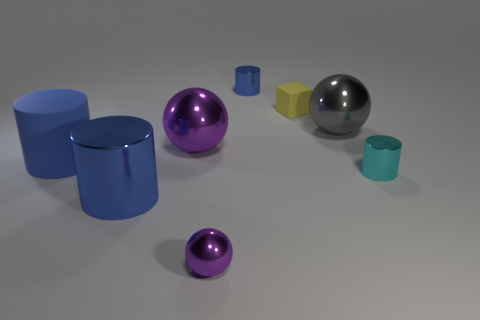Subtract all blue cylinders. How many were subtracted if there are1blue cylinders left? 2 Subtract all red blocks. How many blue cylinders are left? 3 Subtract all green cylinders. Subtract all purple spheres. How many cylinders are left? 4 Add 2 purple shiny spheres. How many objects exist? 10 Subtract all balls. How many objects are left? 5 Add 3 big metal objects. How many big metal objects exist? 6 Subtract 0 red spheres. How many objects are left? 8 Subtract all cylinders. Subtract all tiny shiny objects. How many objects are left? 1 Add 2 matte cylinders. How many matte cylinders are left? 3 